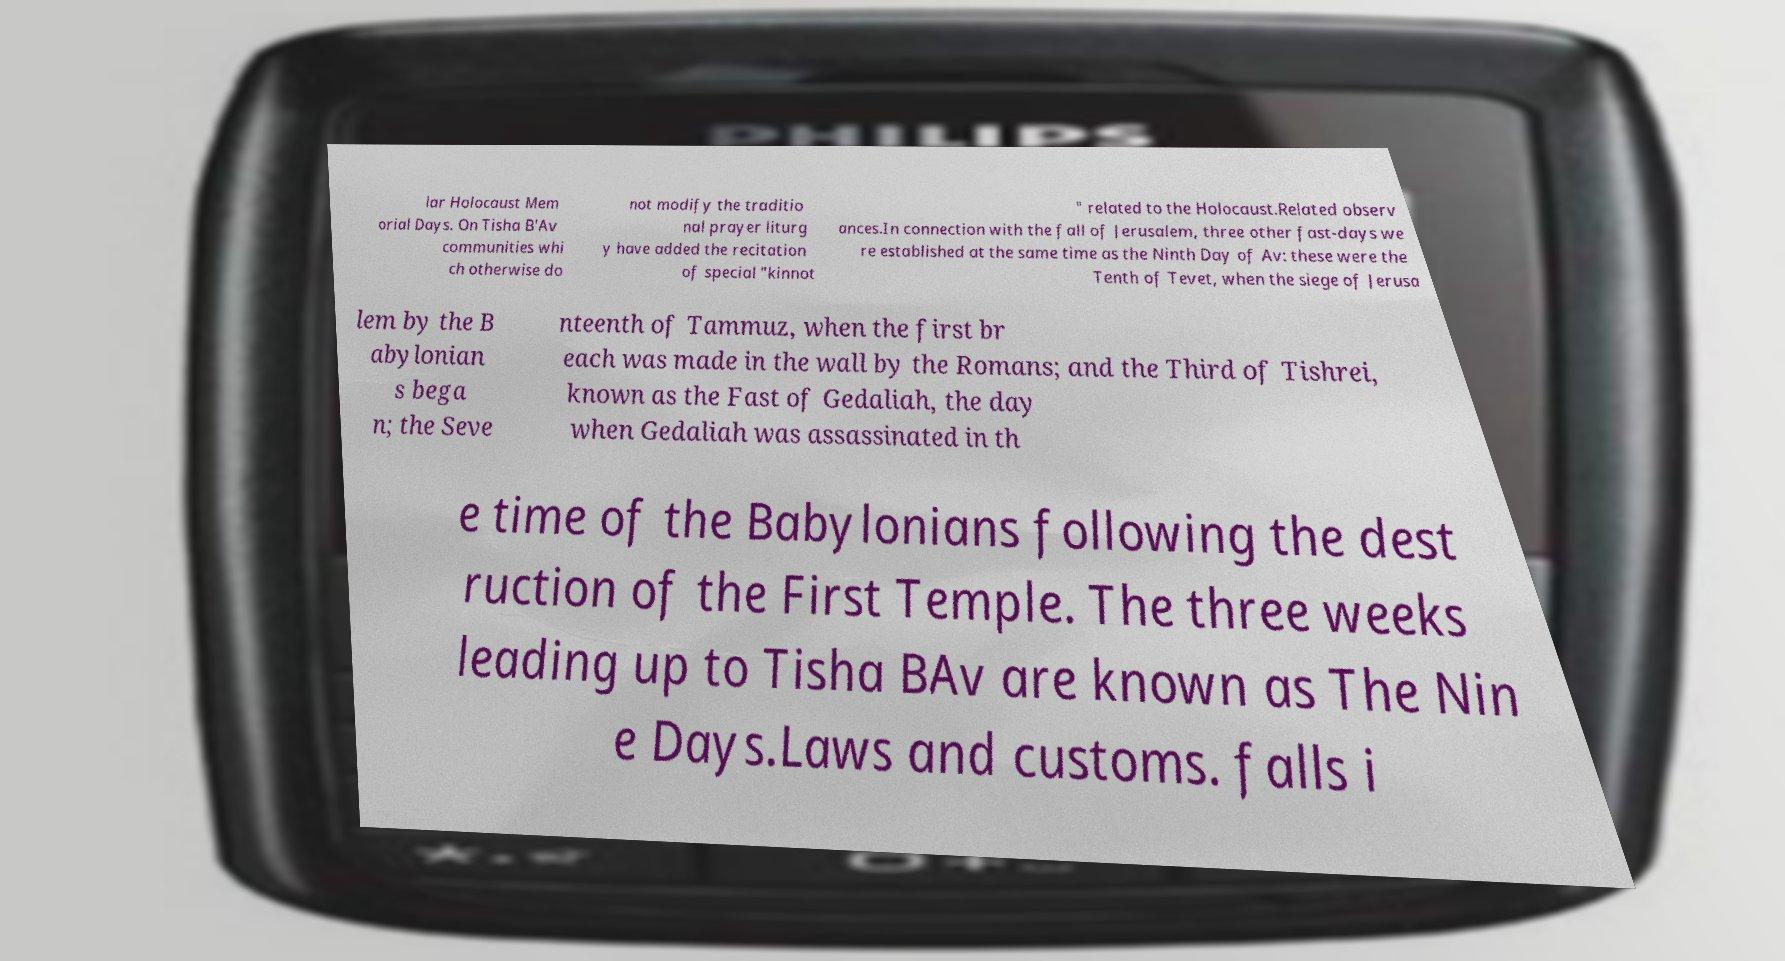Can you accurately transcribe the text from the provided image for me? lar Holocaust Mem orial Days. On Tisha B'Av communities whi ch otherwise do not modify the traditio nal prayer liturg y have added the recitation of special "kinnot " related to the Holocaust.Related observ ances.In connection with the fall of Jerusalem, three other fast-days we re established at the same time as the Ninth Day of Av: these were the Tenth of Tevet, when the siege of Jerusa lem by the B abylonian s bega n; the Seve nteenth of Tammuz, when the first br each was made in the wall by the Romans; and the Third of Tishrei, known as the Fast of Gedaliah, the day when Gedaliah was assassinated in th e time of the Babylonians following the dest ruction of the First Temple. The three weeks leading up to Tisha BAv are known as The Nin e Days.Laws and customs. falls i 